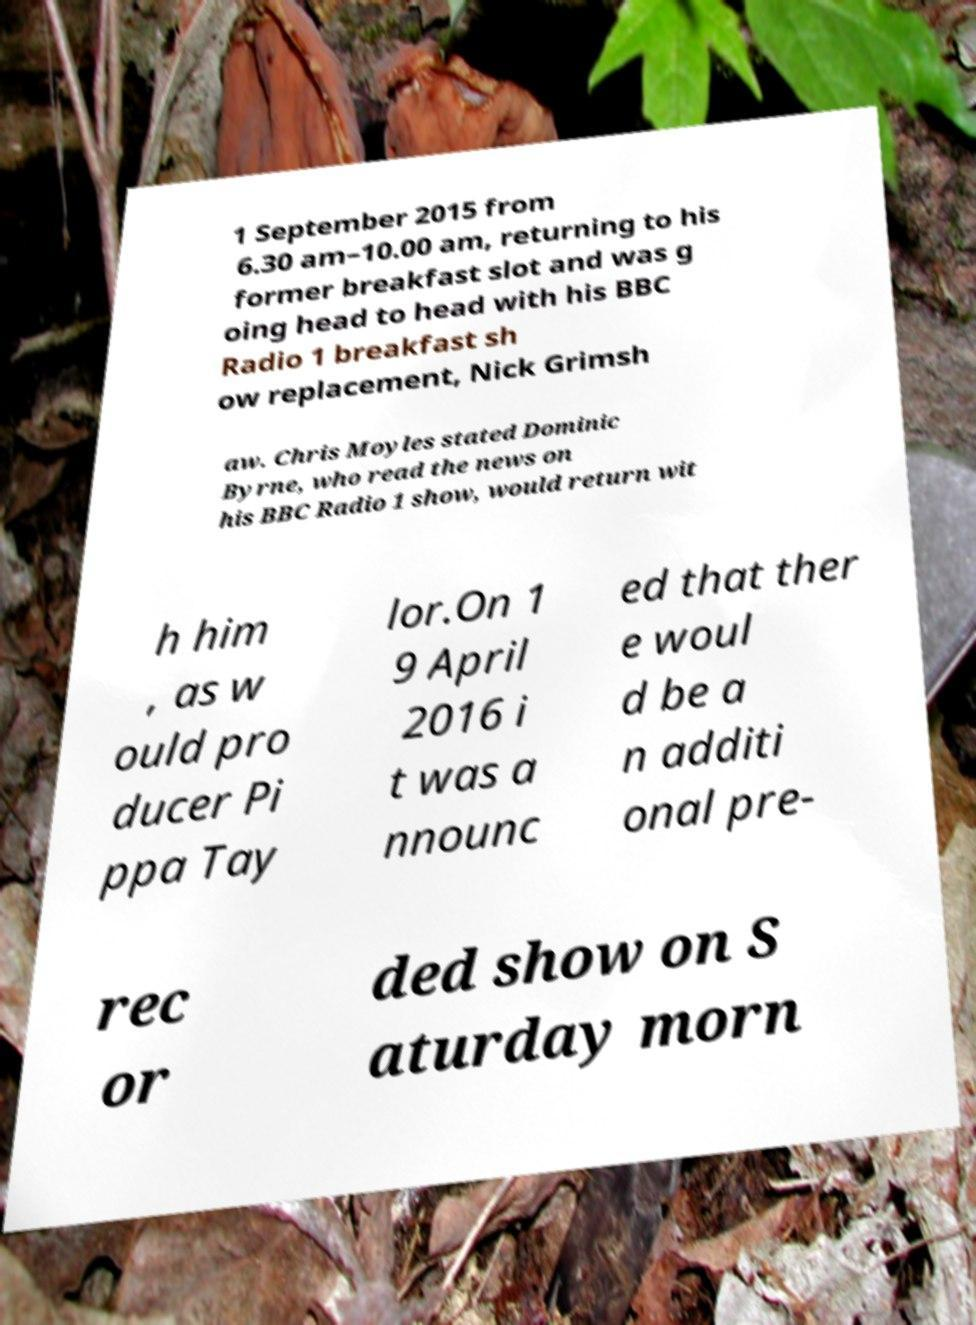There's text embedded in this image that I need extracted. Can you transcribe it verbatim? 1 September 2015 from 6.30 am–10.00 am, returning to his former breakfast slot and was g oing head to head with his BBC Radio 1 breakfast sh ow replacement, Nick Grimsh aw. Chris Moyles stated Dominic Byrne, who read the news on his BBC Radio 1 show, would return wit h him , as w ould pro ducer Pi ppa Tay lor.On 1 9 April 2016 i t was a nnounc ed that ther e woul d be a n additi onal pre- rec or ded show on S aturday morn 